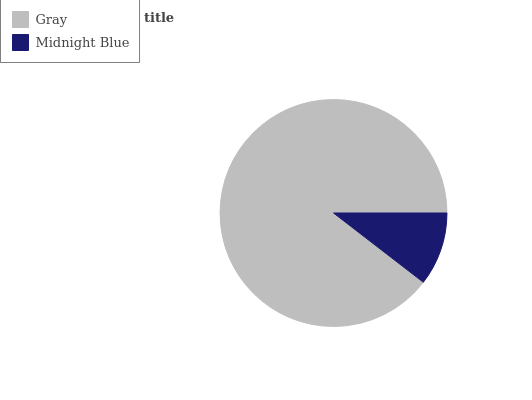Is Midnight Blue the minimum?
Answer yes or no. Yes. Is Gray the maximum?
Answer yes or no. Yes. Is Midnight Blue the maximum?
Answer yes or no. No. Is Gray greater than Midnight Blue?
Answer yes or no. Yes. Is Midnight Blue less than Gray?
Answer yes or no. Yes. Is Midnight Blue greater than Gray?
Answer yes or no. No. Is Gray less than Midnight Blue?
Answer yes or no. No. Is Gray the high median?
Answer yes or no. Yes. Is Midnight Blue the low median?
Answer yes or no. Yes. Is Midnight Blue the high median?
Answer yes or no. No. Is Gray the low median?
Answer yes or no. No. 